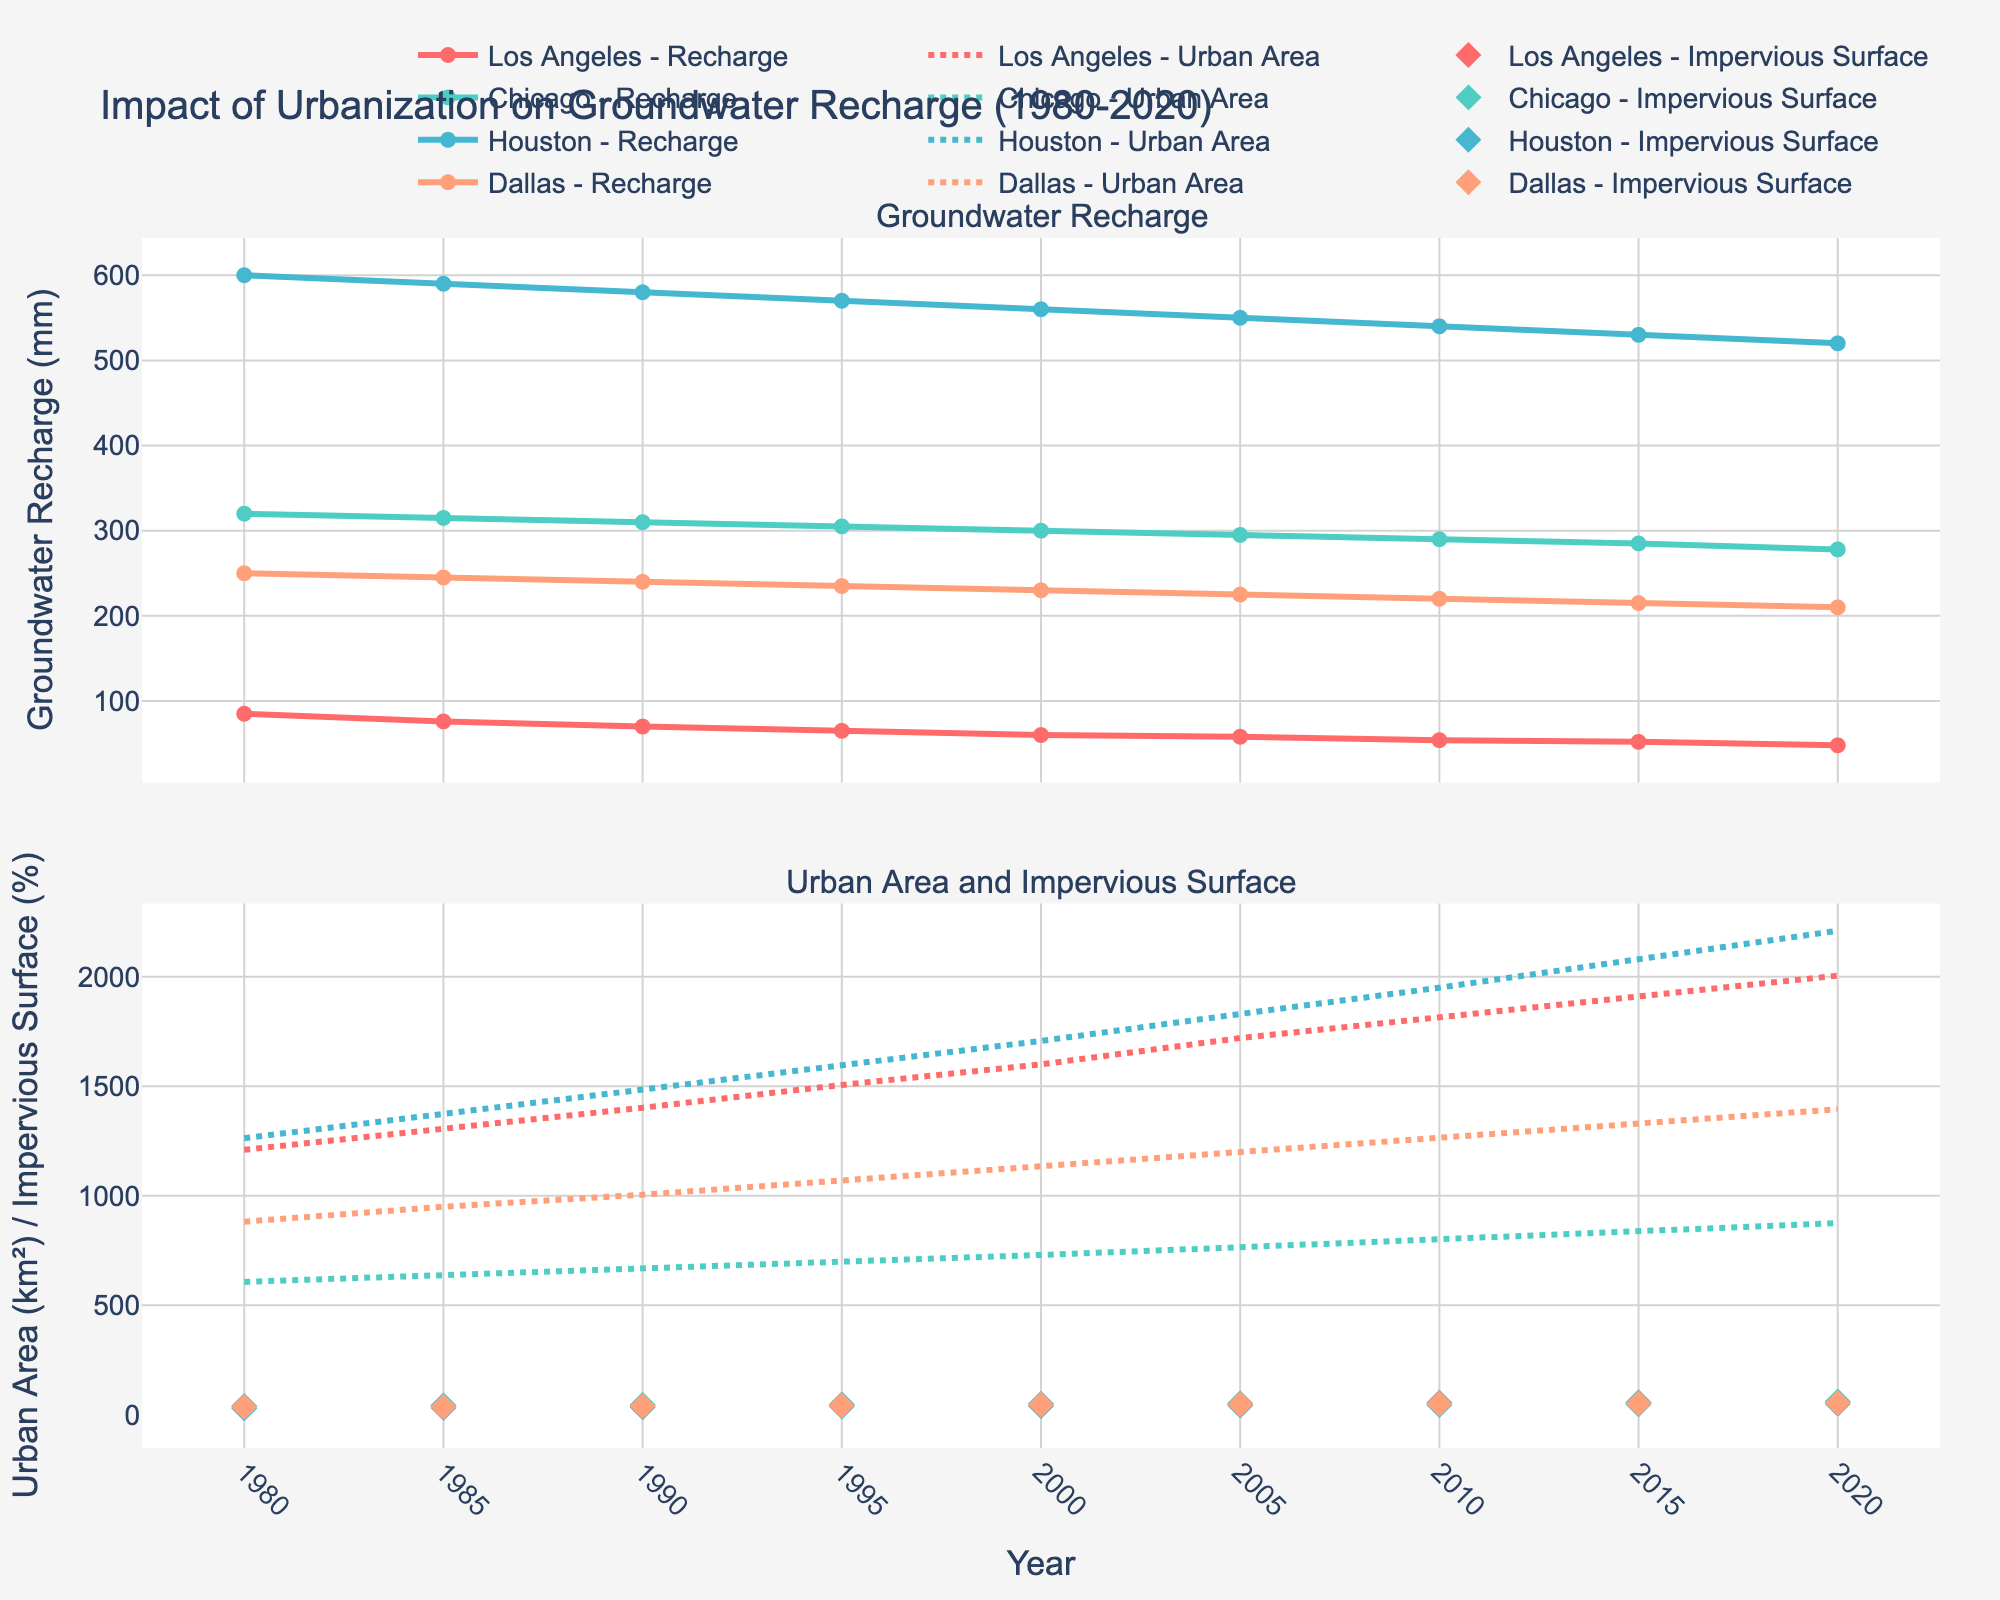What's the title of the figure? Look at the top center of the figure to find the title text.
Answer: Impact of Urbanization on Groundwater Recharge (1980-2020) How has the groundwater recharge in Los Angeles changed from 1980 to 2020? Identify the line representing Los Angeles in the Groundwater Recharge subplot. Observe the change in y-value (Groundwater Recharge) from the year 1980 to 2020.
Answer: It decreased from 85 mm to 48 mm Which city has the highest groundwater recharge in 1980? Locate the first data point for each city in the Groundwater Recharge subplot, then compare their y-values.
Answer: Houston How has the urban area in Chicago changed over the years? Identify the line representing Chicago in the Urban Area subplot. Observe how the x-value (year) correlates with the change in y-value (urban area).
Answer: It has steadily increased from 607 km² in 1980 to 875 km² in 2020 Compare the impervious surface percentage of Dallas in 2005 and 2020. Look for the markers representing Dallas in the Impervious Surface subplot for the years 2005 and 2020; compare their y-values.
Answer: It increased from 47% to 55% Which city had the lowest groundwater recharge in 2020? Examine the last data points for each city in the Groundwater Recharge subplot and compare the y-values.
Answer: Los Angeles In which city and year was the highest annual precipitation recorded? Locate the highest y-value in the Annual Precipitation subplot and identify the corresponding city and year.
Answer: Houston, 1980 What trend can be seen in Houston's impervious surface percentage from 1980 to 2020? Follow the markers representing Houston in the Impervious Surface subplot from the left to the right end to determine any trends.
Answer: It increased from 30% to 50% Calculate the average urban area in Los Angeles in 1980 and 2020. Note the urban area values for Los Angeles in 1980 (1210 km²) and 2020 (2005 km²), then calculate their average: (1210 + 2005) / 2.
Answer: 1607.5 km² 